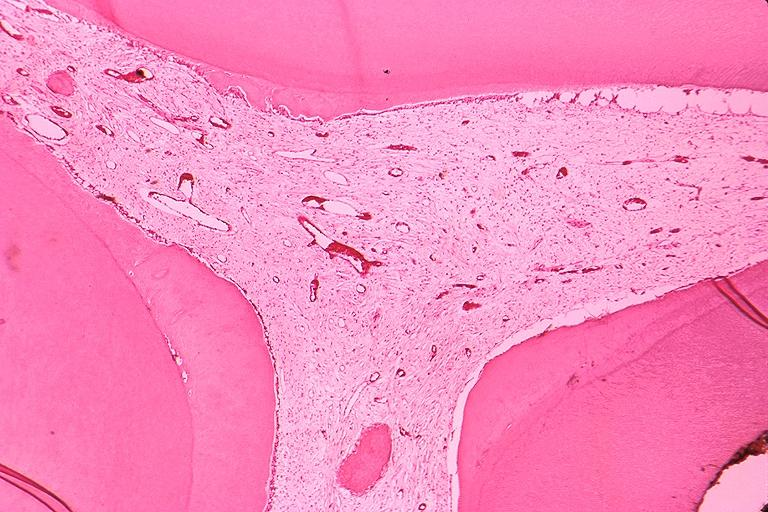does very good example show secondary dentin and pulp calcification?
Answer the question using a single word or phrase. No 